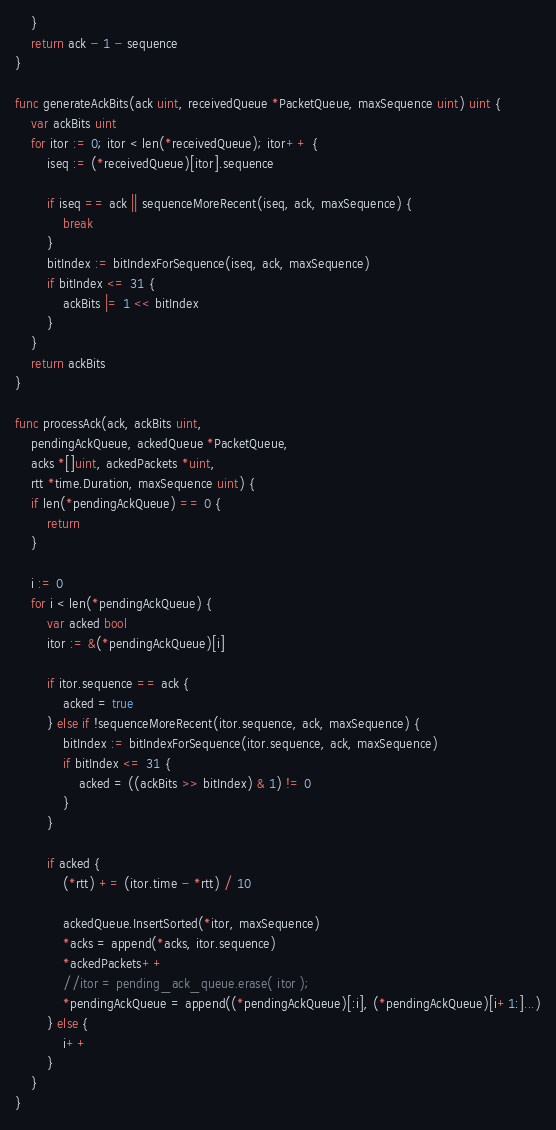<code> <loc_0><loc_0><loc_500><loc_500><_Go_>	}
	return ack - 1 - sequence
}

func generateAckBits(ack uint, receivedQueue *PacketQueue, maxSequence uint) uint {
	var ackBits uint
	for itor := 0; itor < len(*receivedQueue); itor++ {
		iseq := (*receivedQueue)[itor].sequence

		if iseq == ack || sequenceMoreRecent(iseq, ack, maxSequence) {
			break
		}
		bitIndex := bitIndexForSequence(iseq, ack, maxSequence)
		if bitIndex <= 31 {
			ackBits |= 1 << bitIndex
		}
	}
	return ackBits
}

func processAck(ack, ackBits uint,
	pendingAckQueue, ackedQueue *PacketQueue,
	acks *[]uint, ackedPackets *uint,
	rtt *time.Duration, maxSequence uint) {
	if len(*pendingAckQueue) == 0 {
		return
	}

	i := 0
	for i < len(*pendingAckQueue) {
		var acked bool
		itor := &(*pendingAckQueue)[i]

		if itor.sequence == ack {
			acked = true
		} else if !sequenceMoreRecent(itor.sequence, ack, maxSequence) {
			bitIndex := bitIndexForSequence(itor.sequence, ack, maxSequence)
			if bitIndex <= 31 {
				acked = ((ackBits >> bitIndex) & 1) != 0
			}
		}

		if acked {
			(*rtt) += (itor.time - *rtt) / 10

			ackedQueue.InsertSorted(*itor, maxSequence)
			*acks = append(*acks, itor.sequence)
			*ackedPackets++
			//itor = pending_ack_queue.erase( itor );
			*pendingAckQueue = append((*pendingAckQueue)[:i], (*pendingAckQueue)[i+1:]...)
		} else {
			i++
		}
	}
}
</code> 